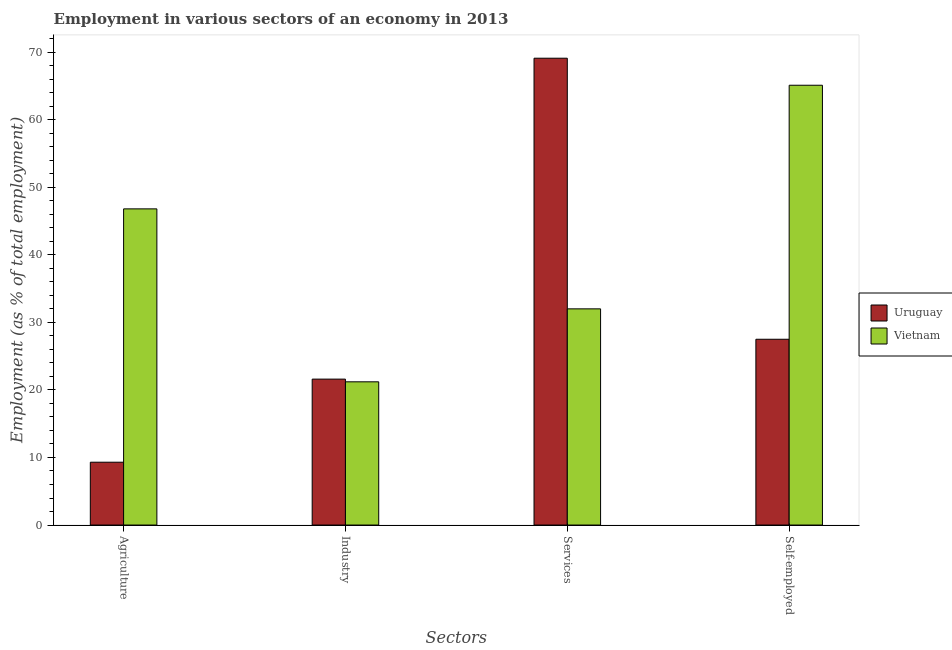How many groups of bars are there?
Offer a terse response. 4. How many bars are there on the 4th tick from the right?
Offer a very short reply. 2. What is the label of the 3rd group of bars from the left?
Your answer should be compact. Services. What is the percentage of workers in industry in Vietnam?
Your answer should be very brief. 21.2. Across all countries, what is the maximum percentage of workers in agriculture?
Your answer should be compact. 46.8. Across all countries, what is the minimum percentage of workers in agriculture?
Give a very brief answer. 9.3. In which country was the percentage of workers in services maximum?
Ensure brevity in your answer.  Uruguay. In which country was the percentage of workers in agriculture minimum?
Give a very brief answer. Uruguay. What is the total percentage of self employed workers in the graph?
Your response must be concise. 92.6. What is the difference between the percentage of workers in agriculture in Uruguay and that in Vietnam?
Offer a terse response. -37.5. What is the difference between the percentage of workers in agriculture in Vietnam and the percentage of workers in services in Uruguay?
Provide a short and direct response. -22.3. What is the average percentage of workers in services per country?
Your answer should be compact. 50.55. What is the difference between the percentage of workers in services and percentage of workers in agriculture in Vietnam?
Provide a succinct answer. -14.8. In how many countries, is the percentage of workers in services greater than 14 %?
Your answer should be compact. 2. What is the ratio of the percentage of workers in services in Vietnam to that in Uruguay?
Your response must be concise. 0.46. Is the percentage of workers in agriculture in Vietnam less than that in Uruguay?
Provide a succinct answer. No. Is the difference between the percentage of workers in industry in Vietnam and Uruguay greater than the difference between the percentage of self employed workers in Vietnam and Uruguay?
Keep it short and to the point. No. What is the difference between the highest and the second highest percentage of self employed workers?
Provide a succinct answer. 37.6. What is the difference between the highest and the lowest percentage of workers in services?
Provide a succinct answer. 37.1. Is the sum of the percentage of self employed workers in Uruguay and Vietnam greater than the maximum percentage of workers in industry across all countries?
Ensure brevity in your answer.  Yes. Is it the case that in every country, the sum of the percentage of workers in services and percentage of self employed workers is greater than the sum of percentage of workers in agriculture and percentage of workers in industry?
Make the answer very short. Yes. What does the 1st bar from the left in Self-employed represents?
Offer a terse response. Uruguay. What does the 1st bar from the right in Self-employed represents?
Your answer should be very brief. Vietnam. Is it the case that in every country, the sum of the percentage of workers in agriculture and percentage of workers in industry is greater than the percentage of workers in services?
Provide a succinct answer. No. Are all the bars in the graph horizontal?
Provide a short and direct response. No. Are the values on the major ticks of Y-axis written in scientific E-notation?
Provide a succinct answer. No. Does the graph contain any zero values?
Give a very brief answer. No. Where does the legend appear in the graph?
Provide a succinct answer. Center right. How many legend labels are there?
Your answer should be very brief. 2. How are the legend labels stacked?
Give a very brief answer. Vertical. What is the title of the graph?
Your answer should be compact. Employment in various sectors of an economy in 2013. What is the label or title of the X-axis?
Provide a short and direct response. Sectors. What is the label or title of the Y-axis?
Offer a terse response. Employment (as % of total employment). What is the Employment (as % of total employment) in Uruguay in Agriculture?
Your answer should be compact. 9.3. What is the Employment (as % of total employment) of Vietnam in Agriculture?
Ensure brevity in your answer.  46.8. What is the Employment (as % of total employment) of Uruguay in Industry?
Provide a succinct answer. 21.6. What is the Employment (as % of total employment) in Vietnam in Industry?
Offer a terse response. 21.2. What is the Employment (as % of total employment) of Uruguay in Services?
Give a very brief answer. 69.1. What is the Employment (as % of total employment) of Vietnam in Services?
Your response must be concise. 32. What is the Employment (as % of total employment) in Vietnam in Self-employed?
Your response must be concise. 65.1. Across all Sectors, what is the maximum Employment (as % of total employment) of Uruguay?
Ensure brevity in your answer.  69.1. Across all Sectors, what is the maximum Employment (as % of total employment) in Vietnam?
Provide a short and direct response. 65.1. Across all Sectors, what is the minimum Employment (as % of total employment) in Uruguay?
Offer a very short reply. 9.3. Across all Sectors, what is the minimum Employment (as % of total employment) of Vietnam?
Provide a short and direct response. 21.2. What is the total Employment (as % of total employment) of Uruguay in the graph?
Make the answer very short. 127.5. What is the total Employment (as % of total employment) of Vietnam in the graph?
Your answer should be very brief. 165.1. What is the difference between the Employment (as % of total employment) in Uruguay in Agriculture and that in Industry?
Your answer should be very brief. -12.3. What is the difference between the Employment (as % of total employment) of Vietnam in Agriculture and that in Industry?
Provide a succinct answer. 25.6. What is the difference between the Employment (as % of total employment) in Uruguay in Agriculture and that in Services?
Ensure brevity in your answer.  -59.8. What is the difference between the Employment (as % of total employment) of Vietnam in Agriculture and that in Services?
Provide a succinct answer. 14.8. What is the difference between the Employment (as % of total employment) of Uruguay in Agriculture and that in Self-employed?
Ensure brevity in your answer.  -18.2. What is the difference between the Employment (as % of total employment) in Vietnam in Agriculture and that in Self-employed?
Provide a succinct answer. -18.3. What is the difference between the Employment (as % of total employment) in Uruguay in Industry and that in Services?
Give a very brief answer. -47.5. What is the difference between the Employment (as % of total employment) of Vietnam in Industry and that in Services?
Keep it short and to the point. -10.8. What is the difference between the Employment (as % of total employment) in Vietnam in Industry and that in Self-employed?
Your answer should be compact. -43.9. What is the difference between the Employment (as % of total employment) of Uruguay in Services and that in Self-employed?
Offer a very short reply. 41.6. What is the difference between the Employment (as % of total employment) of Vietnam in Services and that in Self-employed?
Provide a short and direct response. -33.1. What is the difference between the Employment (as % of total employment) in Uruguay in Agriculture and the Employment (as % of total employment) in Vietnam in Industry?
Keep it short and to the point. -11.9. What is the difference between the Employment (as % of total employment) of Uruguay in Agriculture and the Employment (as % of total employment) of Vietnam in Services?
Your response must be concise. -22.7. What is the difference between the Employment (as % of total employment) in Uruguay in Agriculture and the Employment (as % of total employment) in Vietnam in Self-employed?
Ensure brevity in your answer.  -55.8. What is the difference between the Employment (as % of total employment) in Uruguay in Industry and the Employment (as % of total employment) in Vietnam in Self-employed?
Provide a succinct answer. -43.5. What is the average Employment (as % of total employment) of Uruguay per Sectors?
Provide a succinct answer. 31.88. What is the average Employment (as % of total employment) in Vietnam per Sectors?
Your response must be concise. 41.27. What is the difference between the Employment (as % of total employment) of Uruguay and Employment (as % of total employment) of Vietnam in Agriculture?
Offer a terse response. -37.5. What is the difference between the Employment (as % of total employment) of Uruguay and Employment (as % of total employment) of Vietnam in Services?
Offer a very short reply. 37.1. What is the difference between the Employment (as % of total employment) of Uruguay and Employment (as % of total employment) of Vietnam in Self-employed?
Ensure brevity in your answer.  -37.6. What is the ratio of the Employment (as % of total employment) of Uruguay in Agriculture to that in Industry?
Provide a short and direct response. 0.43. What is the ratio of the Employment (as % of total employment) in Vietnam in Agriculture to that in Industry?
Your response must be concise. 2.21. What is the ratio of the Employment (as % of total employment) in Uruguay in Agriculture to that in Services?
Provide a short and direct response. 0.13. What is the ratio of the Employment (as % of total employment) in Vietnam in Agriculture to that in Services?
Provide a succinct answer. 1.46. What is the ratio of the Employment (as % of total employment) in Uruguay in Agriculture to that in Self-employed?
Provide a succinct answer. 0.34. What is the ratio of the Employment (as % of total employment) of Vietnam in Agriculture to that in Self-employed?
Give a very brief answer. 0.72. What is the ratio of the Employment (as % of total employment) of Uruguay in Industry to that in Services?
Offer a terse response. 0.31. What is the ratio of the Employment (as % of total employment) of Vietnam in Industry to that in Services?
Your answer should be very brief. 0.66. What is the ratio of the Employment (as % of total employment) in Uruguay in Industry to that in Self-employed?
Your answer should be very brief. 0.79. What is the ratio of the Employment (as % of total employment) in Vietnam in Industry to that in Self-employed?
Make the answer very short. 0.33. What is the ratio of the Employment (as % of total employment) of Uruguay in Services to that in Self-employed?
Offer a terse response. 2.51. What is the ratio of the Employment (as % of total employment) of Vietnam in Services to that in Self-employed?
Keep it short and to the point. 0.49. What is the difference between the highest and the second highest Employment (as % of total employment) of Uruguay?
Your answer should be compact. 41.6. What is the difference between the highest and the second highest Employment (as % of total employment) in Vietnam?
Keep it short and to the point. 18.3. What is the difference between the highest and the lowest Employment (as % of total employment) of Uruguay?
Provide a succinct answer. 59.8. What is the difference between the highest and the lowest Employment (as % of total employment) in Vietnam?
Provide a short and direct response. 43.9. 